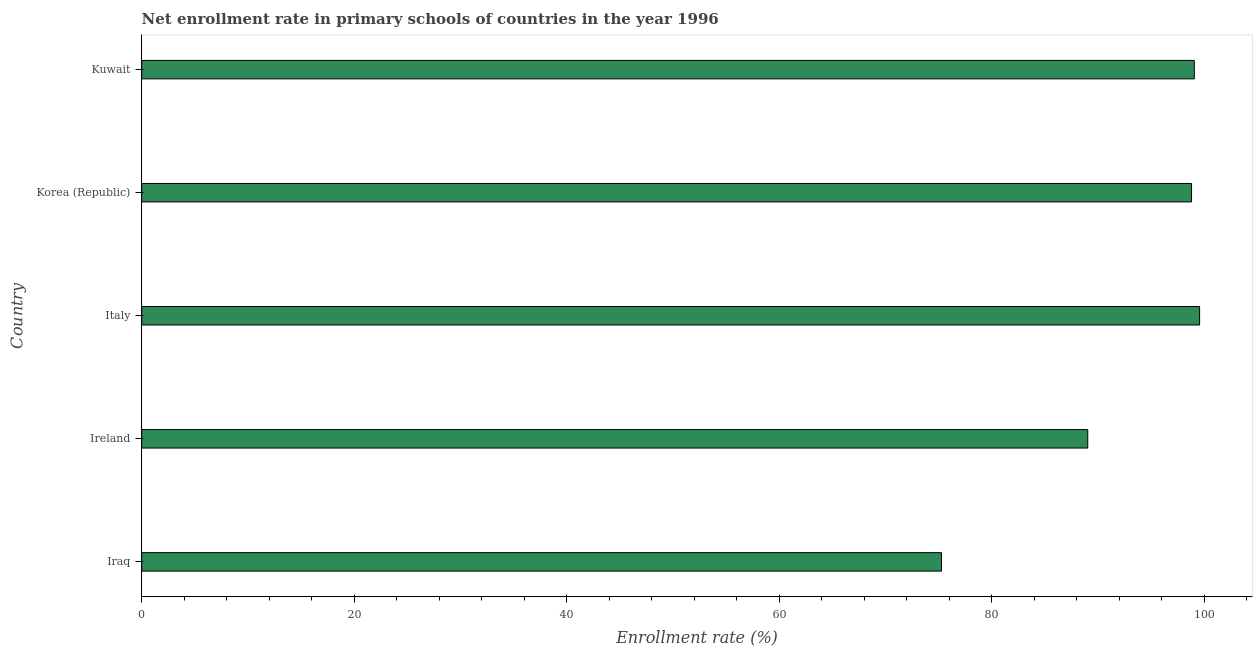Does the graph contain any zero values?
Keep it short and to the point. No. What is the title of the graph?
Provide a succinct answer. Net enrollment rate in primary schools of countries in the year 1996. What is the label or title of the X-axis?
Keep it short and to the point. Enrollment rate (%). What is the label or title of the Y-axis?
Your answer should be very brief. Country. What is the net enrollment rate in primary schools in Korea (Republic)?
Make the answer very short. 98.8. Across all countries, what is the maximum net enrollment rate in primary schools?
Give a very brief answer. 99.56. Across all countries, what is the minimum net enrollment rate in primary schools?
Provide a succinct answer. 75.27. In which country was the net enrollment rate in primary schools maximum?
Make the answer very short. Italy. In which country was the net enrollment rate in primary schools minimum?
Provide a short and direct response. Iraq. What is the sum of the net enrollment rate in primary schools?
Give a very brief answer. 461.74. What is the difference between the net enrollment rate in primary schools in Iraq and Kuwait?
Offer a terse response. -23.8. What is the average net enrollment rate in primary schools per country?
Your answer should be compact. 92.35. What is the median net enrollment rate in primary schools?
Make the answer very short. 98.8. In how many countries, is the net enrollment rate in primary schools greater than 80 %?
Keep it short and to the point. 4. What is the ratio of the net enrollment rate in primary schools in Iraq to that in Korea (Republic)?
Your response must be concise. 0.76. Is the difference between the net enrollment rate in primary schools in Ireland and Kuwait greater than the difference between any two countries?
Ensure brevity in your answer.  No. What is the difference between the highest and the second highest net enrollment rate in primary schools?
Make the answer very short. 0.5. Is the sum of the net enrollment rate in primary schools in Korea (Republic) and Kuwait greater than the maximum net enrollment rate in primary schools across all countries?
Provide a short and direct response. Yes. What is the difference between the highest and the lowest net enrollment rate in primary schools?
Ensure brevity in your answer.  24.29. What is the difference between two consecutive major ticks on the X-axis?
Your answer should be compact. 20. Are the values on the major ticks of X-axis written in scientific E-notation?
Your answer should be very brief. No. What is the Enrollment rate (%) in Iraq?
Keep it short and to the point. 75.27. What is the Enrollment rate (%) of Ireland?
Ensure brevity in your answer.  89.04. What is the Enrollment rate (%) of Italy?
Give a very brief answer. 99.56. What is the Enrollment rate (%) in Korea (Republic)?
Offer a terse response. 98.8. What is the Enrollment rate (%) of Kuwait?
Make the answer very short. 99.07. What is the difference between the Enrollment rate (%) in Iraq and Ireland?
Provide a short and direct response. -13.77. What is the difference between the Enrollment rate (%) in Iraq and Italy?
Provide a short and direct response. -24.29. What is the difference between the Enrollment rate (%) in Iraq and Korea (Republic)?
Keep it short and to the point. -23.54. What is the difference between the Enrollment rate (%) in Iraq and Kuwait?
Provide a succinct answer. -23.8. What is the difference between the Enrollment rate (%) in Ireland and Italy?
Keep it short and to the point. -10.53. What is the difference between the Enrollment rate (%) in Ireland and Korea (Republic)?
Provide a short and direct response. -9.77. What is the difference between the Enrollment rate (%) in Ireland and Kuwait?
Provide a succinct answer. -10.03. What is the difference between the Enrollment rate (%) in Italy and Korea (Republic)?
Offer a terse response. 0.76. What is the difference between the Enrollment rate (%) in Italy and Kuwait?
Provide a succinct answer. 0.5. What is the difference between the Enrollment rate (%) in Korea (Republic) and Kuwait?
Provide a succinct answer. -0.26. What is the ratio of the Enrollment rate (%) in Iraq to that in Ireland?
Provide a succinct answer. 0.84. What is the ratio of the Enrollment rate (%) in Iraq to that in Italy?
Make the answer very short. 0.76. What is the ratio of the Enrollment rate (%) in Iraq to that in Korea (Republic)?
Offer a very short reply. 0.76. What is the ratio of the Enrollment rate (%) in Iraq to that in Kuwait?
Provide a succinct answer. 0.76. What is the ratio of the Enrollment rate (%) in Ireland to that in Italy?
Keep it short and to the point. 0.89. What is the ratio of the Enrollment rate (%) in Ireland to that in Korea (Republic)?
Your answer should be compact. 0.9. What is the ratio of the Enrollment rate (%) in Ireland to that in Kuwait?
Offer a terse response. 0.9. What is the ratio of the Enrollment rate (%) in Italy to that in Korea (Republic)?
Provide a succinct answer. 1.01. 